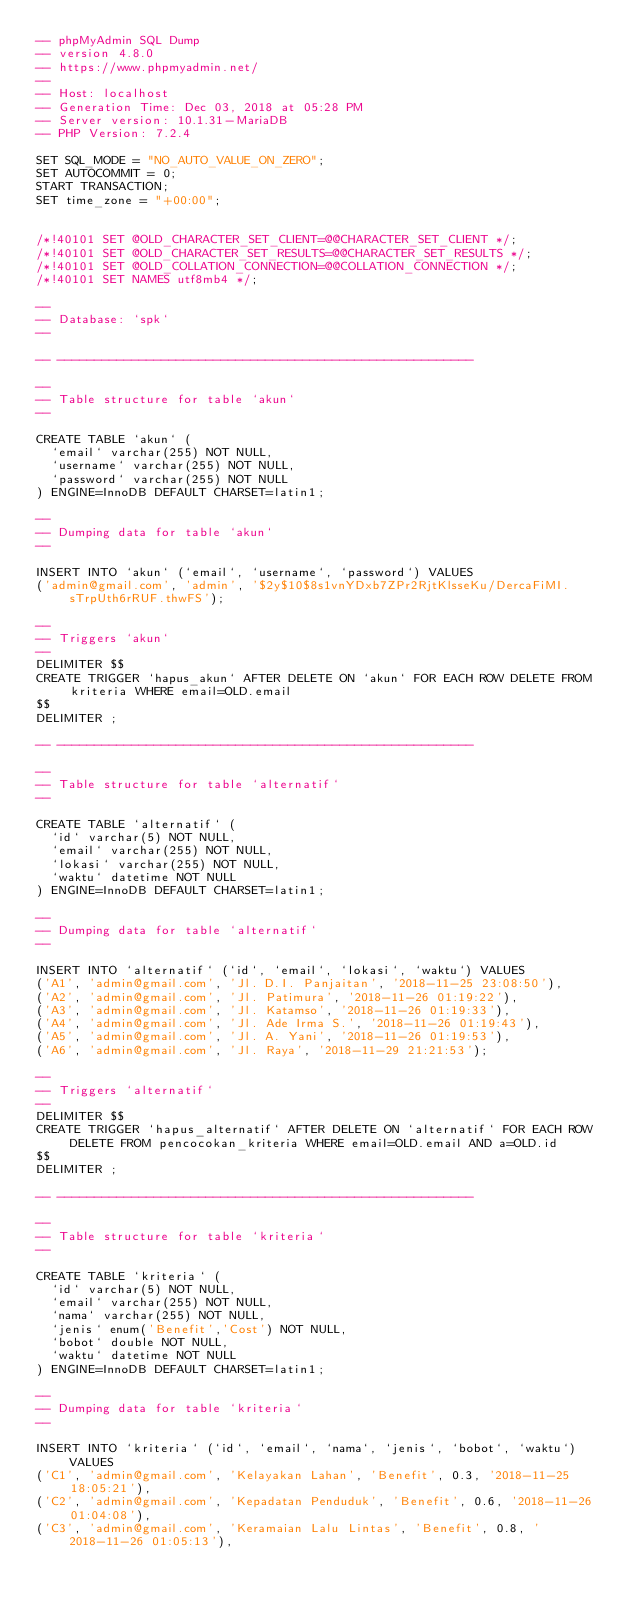<code> <loc_0><loc_0><loc_500><loc_500><_SQL_>-- phpMyAdmin SQL Dump
-- version 4.8.0
-- https://www.phpmyadmin.net/
--
-- Host: localhost
-- Generation Time: Dec 03, 2018 at 05:28 PM
-- Server version: 10.1.31-MariaDB
-- PHP Version: 7.2.4

SET SQL_MODE = "NO_AUTO_VALUE_ON_ZERO";
SET AUTOCOMMIT = 0;
START TRANSACTION;
SET time_zone = "+00:00";


/*!40101 SET @OLD_CHARACTER_SET_CLIENT=@@CHARACTER_SET_CLIENT */;
/*!40101 SET @OLD_CHARACTER_SET_RESULTS=@@CHARACTER_SET_RESULTS */;
/*!40101 SET @OLD_COLLATION_CONNECTION=@@COLLATION_CONNECTION */;
/*!40101 SET NAMES utf8mb4 */;

--
-- Database: `spk`
--

-- --------------------------------------------------------

--
-- Table structure for table `akun`
--

CREATE TABLE `akun` (
  `email` varchar(255) NOT NULL,
  `username` varchar(255) NOT NULL,
  `password` varchar(255) NOT NULL
) ENGINE=InnoDB DEFAULT CHARSET=latin1;

--
-- Dumping data for table `akun`
--

INSERT INTO `akun` (`email`, `username`, `password`) VALUES
('admin@gmail.com', 'admin', '$2y$10$8s1vnYDxb7ZPr2RjtKlsseKu/DercaFiMI.sTrpUth6rRUF.thwFS');

--
-- Triggers `akun`
--
DELIMITER $$
CREATE TRIGGER `hapus_akun` AFTER DELETE ON `akun` FOR EACH ROW DELETE FROM kriteria WHERE email=OLD.email
$$
DELIMITER ;

-- --------------------------------------------------------

--
-- Table structure for table `alternatif`
--

CREATE TABLE `alternatif` (
  `id` varchar(5) NOT NULL,
  `email` varchar(255) NOT NULL,
  `lokasi` varchar(255) NOT NULL,
  `waktu` datetime NOT NULL
) ENGINE=InnoDB DEFAULT CHARSET=latin1;

--
-- Dumping data for table `alternatif`
--

INSERT INTO `alternatif` (`id`, `email`, `lokasi`, `waktu`) VALUES
('A1', 'admin@gmail.com', 'Jl. D.I. Panjaitan', '2018-11-25 23:08:50'),
('A2', 'admin@gmail.com', 'Jl. Patimura', '2018-11-26 01:19:22'),
('A3', 'admin@gmail.com', 'Jl. Katamso', '2018-11-26 01:19:33'),
('A4', 'admin@gmail.com', 'Jl. Ade Irma S.', '2018-11-26 01:19:43'),
('A5', 'admin@gmail.com', 'Jl. A. Yani', '2018-11-26 01:19:53'),
('A6', 'admin@gmail.com', 'Jl. Raya', '2018-11-29 21:21:53');

--
-- Triggers `alternatif`
--
DELIMITER $$
CREATE TRIGGER `hapus_alternatif` AFTER DELETE ON `alternatif` FOR EACH ROW DELETE FROM pencocokan_kriteria WHERE email=OLD.email AND a=OLD.id
$$
DELIMITER ;

-- --------------------------------------------------------

--
-- Table structure for table `kriteria`
--

CREATE TABLE `kriteria` (
  `id` varchar(5) NOT NULL,
  `email` varchar(255) NOT NULL,
  `nama` varchar(255) NOT NULL,
  `jenis` enum('Benefit','Cost') NOT NULL,
  `bobot` double NOT NULL,
  `waktu` datetime NOT NULL
) ENGINE=InnoDB DEFAULT CHARSET=latin1;

--
-- Dumping data for table `kriteria`
--

INSERT INTO `kriteria` (`id`, `email`, `nama`, `jenis`, `bobot`, `waktu`) VALUES
('C1', 'admin@gmail.com', 'Kelayakan Lahan', 'Benefit', 0.3, '2018-11-25 18:05:21'),
('C2', 'admin@gmail.com', 'Kepadatan Penduduk', 'Benefit', 0.6, '2018-11-26 01:04:08'),
('C3', 'admin@gmail.com', 'Keramaian Lalu Lintas', 'Benefit', 0.8, '2018-11-26 01:05:13'),</code> 